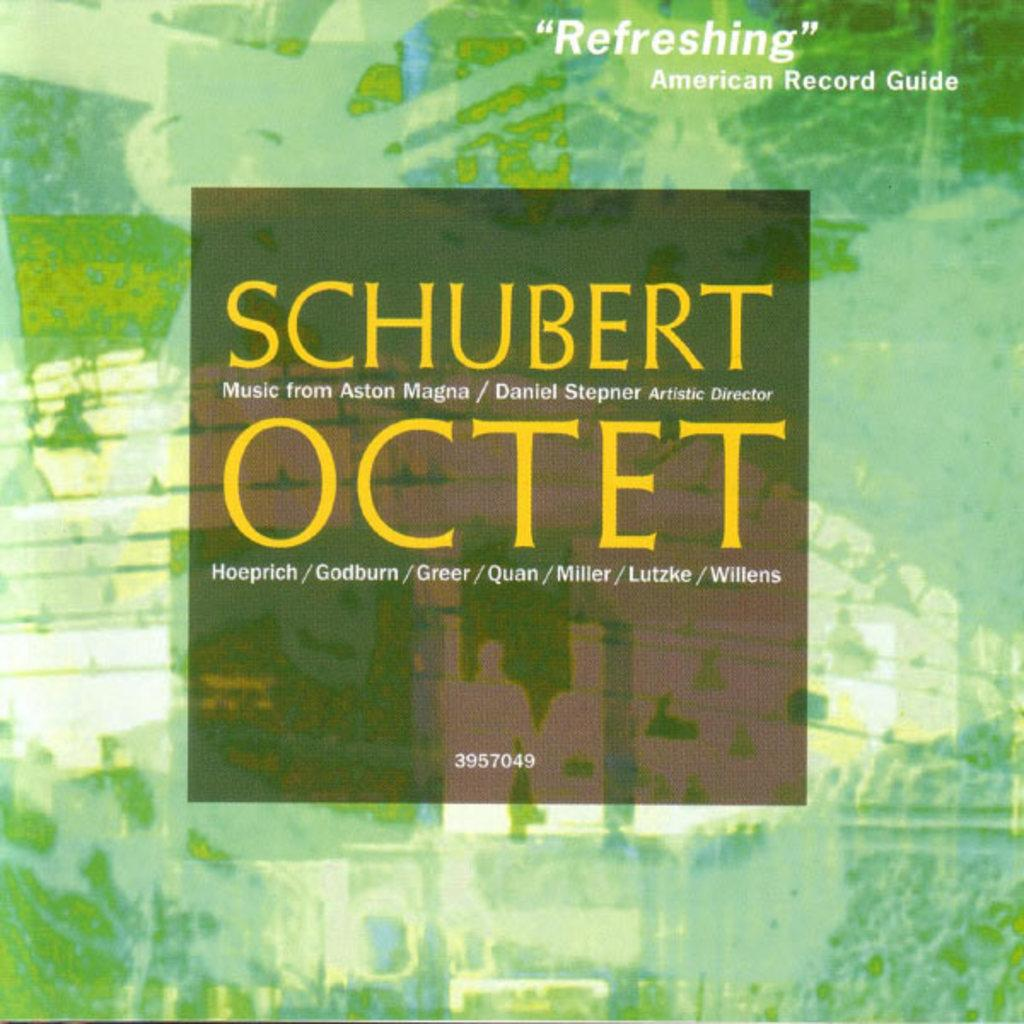Provide a one-sentence caption for the provided image. A CD of Schubert's Ocetet. The cover is green watercolor. A testimonial quote on the cover says "Refreshing - American Record Guide". 